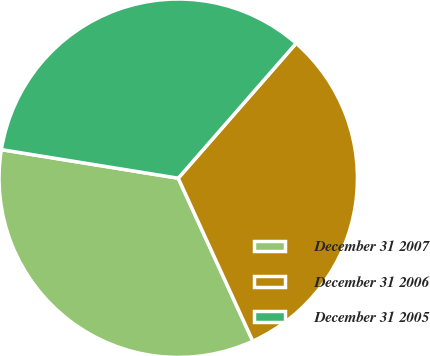<chart> <loc_0><loc_0><loc_500><loc_500><pie_chart><fcel>December 31 2007<fcel>December 31 2006<fcel>December 31 2005<nl><fcel>34.38%<fcel>31.74%<fcel>33.88%<nl></chart> 